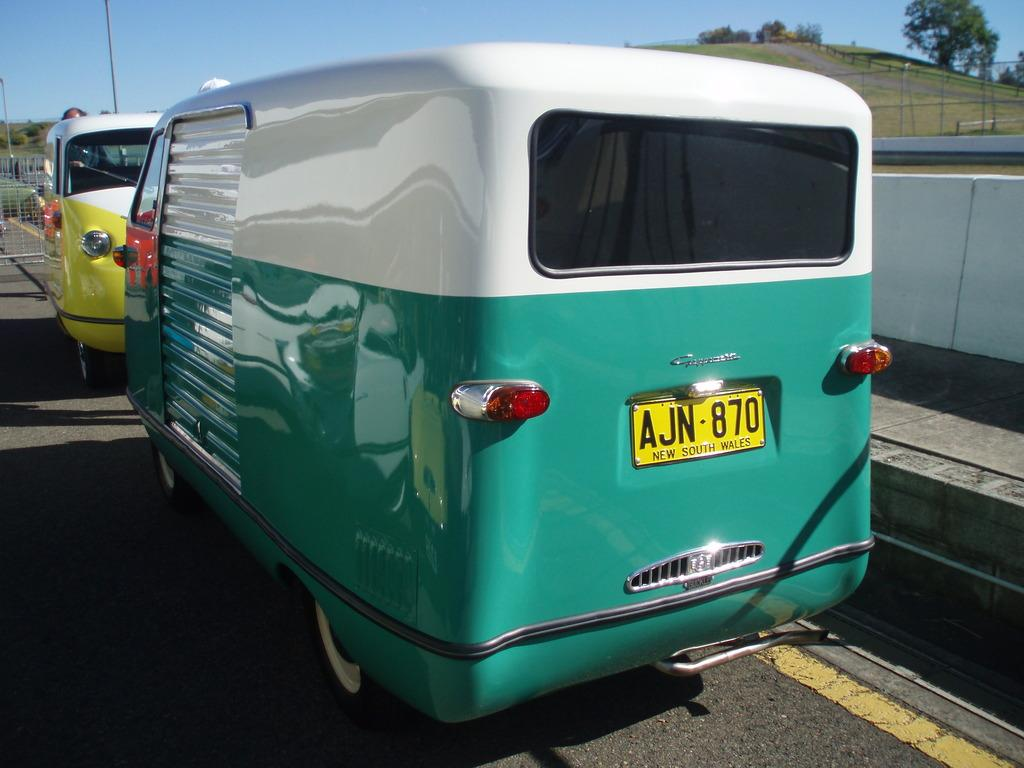<image>
Relay a brief, clear account of the picture shown. A sporty two-colored trailer has a license plate reading AJN-870. 